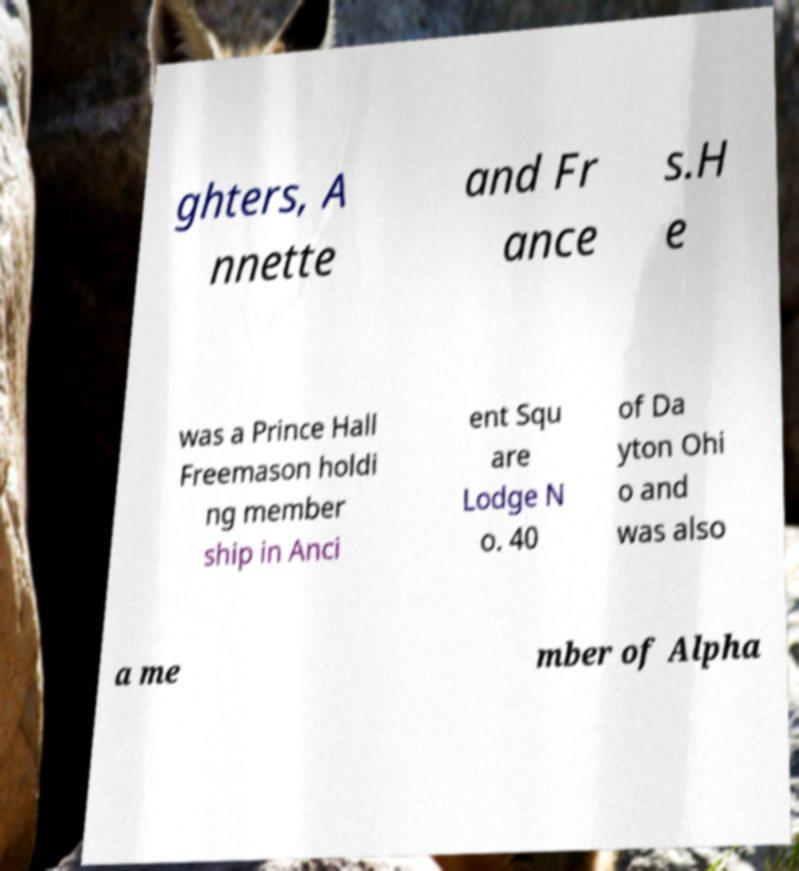Could you extract and type out the text from this image? ghters, A nnette and Fr ance s.H e was a Prince Hall Freemason holdi ng member ship in Anci ent Squ are Lodge N o. 40 of Da yton Ohi o and was also a me mber of Alpha 